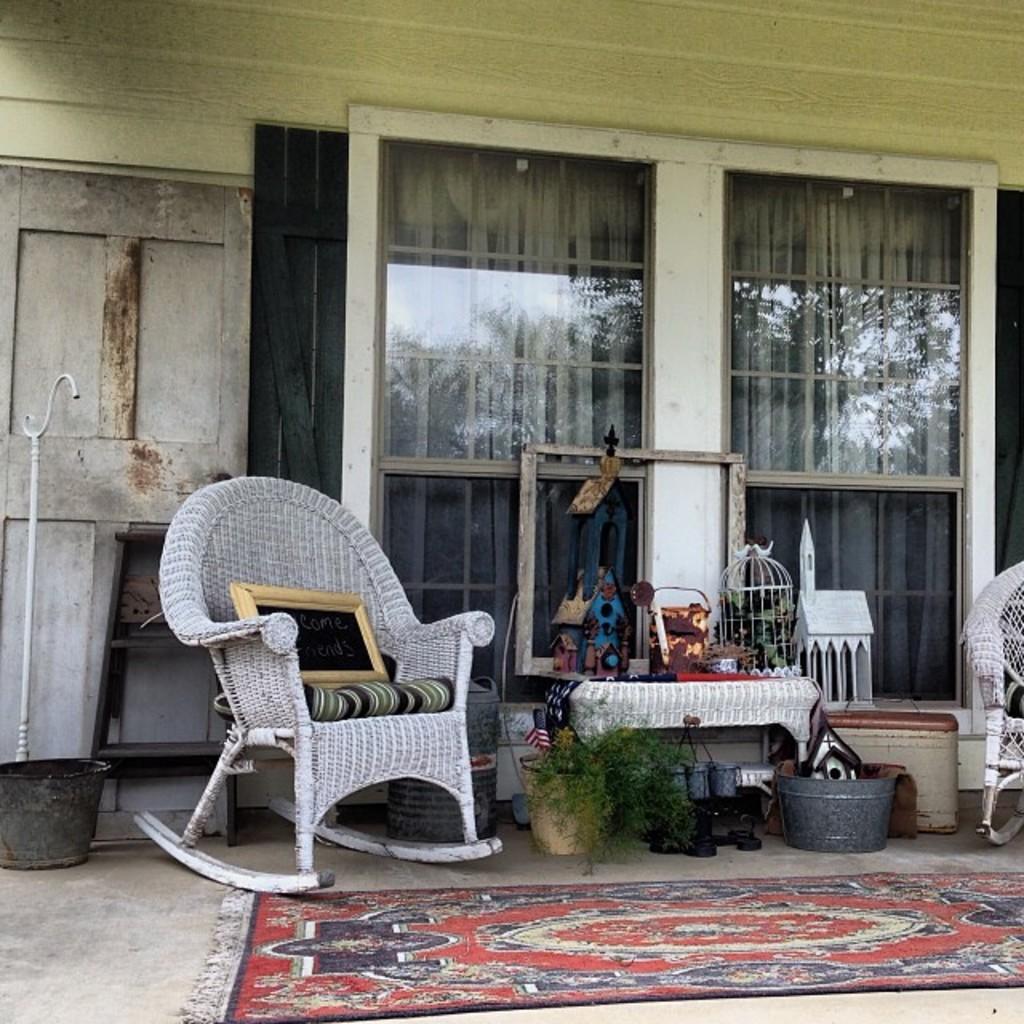Can you describe this image briefly? This image consists of two chairs in white color. At the bottom, there is a floor mat on the floor. On the left, we can see a bucket along with a white color stand. In the background, we can see a door along with glass windows. In the middle, there is a table on which there are many things kept. And we can see a potted plant. 